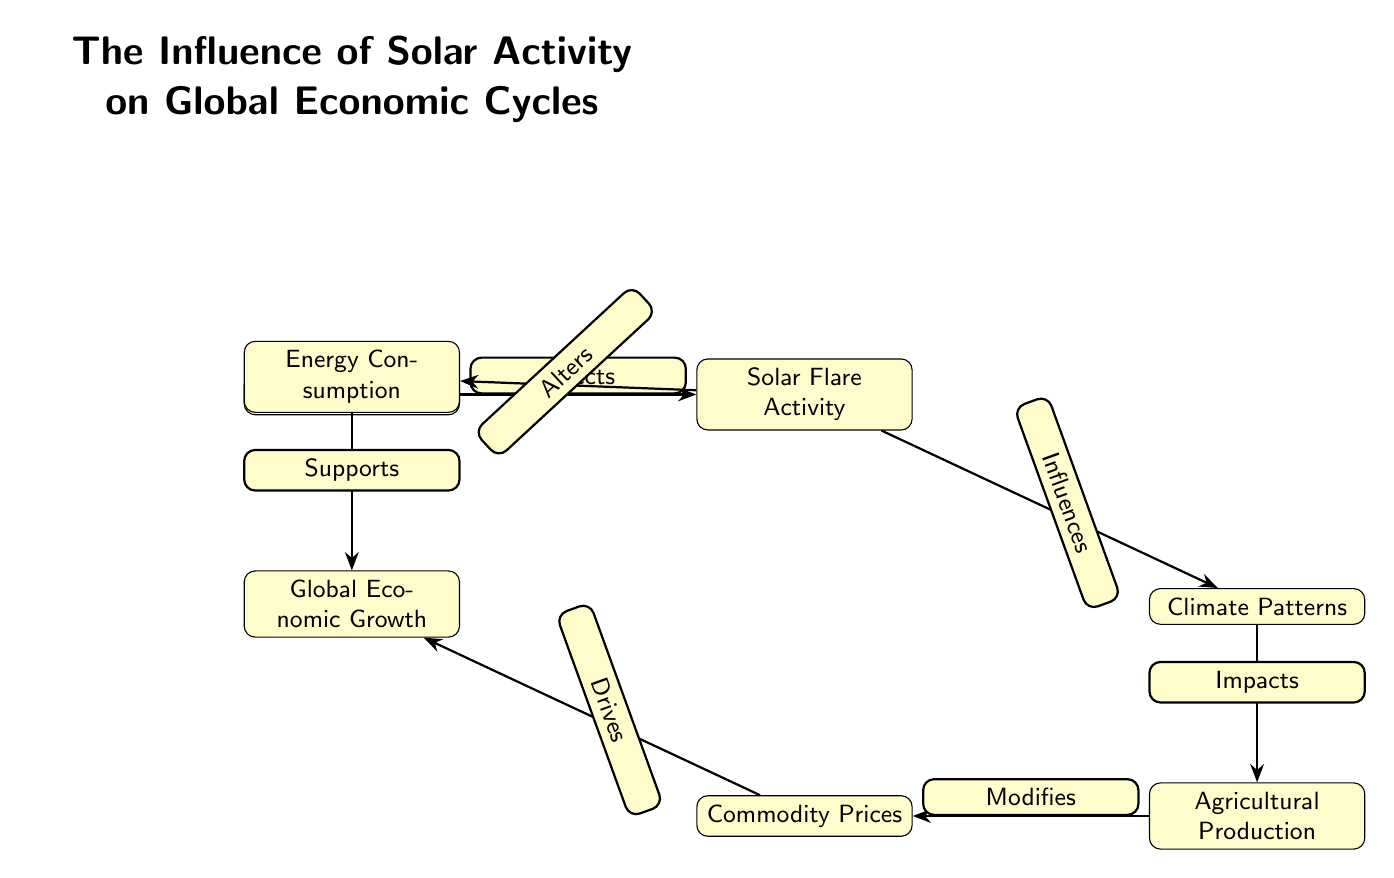What are the two main factors that influence climate patterns? The diagram indicates that both "Sunspot Cycles" and "Solar Flare Activity" affect climate patterns. These two nodes point towards "Climate Patterns," showing their influence.
Answer: Sunspot Cycles, Solar Flare Activity How many nodes are present in the diagram? The diagram contains a total of six nodes: Sunspot Cycles, Solar Flare Activity, Climate Patterns, Agricultural Production, Commodity Prices, and Global Economic Growth. Counting each node gives a total of six.
Answer: 6 Which node does "Agricultural Production" impact? "Agricultural Production" is shown to impact "Commodity Prices" directly as indicated by the edge labeled "Modifies" leading from "Agricultural Production" to "Commodity Prices."
Answer: Commodity Prices What does "Solar Flare Activity" alter? According to the diagram, "Solar Flare Activity" alters "Energy Consumption." This is evident from the edge labeled "Alters" which points from "Solar Flare Activity" to "Energy Consumption."
Answer: Energy Consumption What drives global economic growth according to the diagram? The diagram illustrates that "Commodity Prices" and "Energy Consumption" drive "Global Economic Growth," as both have edges pointing towards it labeled "Drives" and "Supports," respectively.
Answer: Commodity Prices, Energy Consumption How does solar flare activity influence climate patterns? The diagram illustrates the connection by showing that "Solar Flare Activity" influences "Climate Patterns," via the edge labeled "Influences." This implies that changes in solar flare activity can lead to alterations in climate.
Answer: Influences What is the role of "Energy Consumption" in relation to "Global Economic Growth"? The diagram reveals that "Energy Consumption" supports "Global Economic Growth," as indicated by the edge labeled "Supports" leading to "Global Economic Growth." This shows that energy consumption contributes positively to economic growth.
Answer: Supports What significant economic factor is modified by agricultural production? "Commodity Prices" are modified by "Agricultural Production," as indicated by the direct edge labeled "Modifies" connecting the two. This suggests that changes in agricultural output directly affect commodity pricing.
Answer: Commodity Prices What is the effect of climate patterns on agricultural production? The diagram shows that "Climate Patterns" impact "Agricultural Production" with the edge labeled "Impacts." This indicates that variations in climate can influence agricultural yields.
Answer: Impacts 